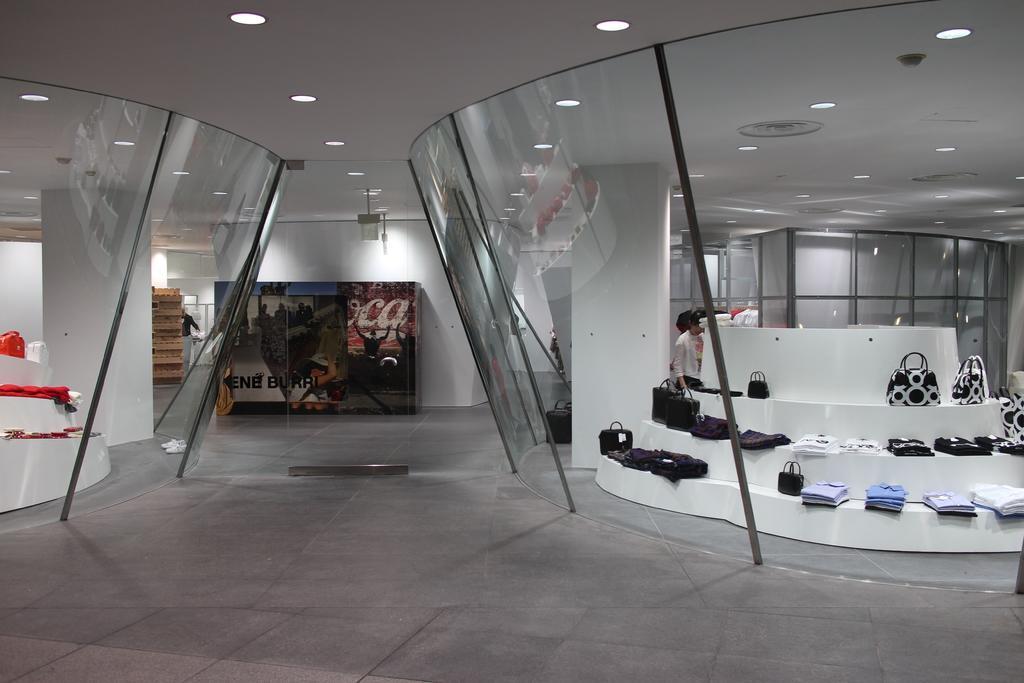How would you summarize this image in a sentence or two? On the right side, we see a stepped table on which the bags and the shirts are placed. Behind that, we see a pillar and a man is standing. Beside him, we see the poles, glass doors and a black bag. On the left side, we see the stepped table on which the clothes are placed. Behind that, we see a pillar, poles and the glass doors. In the middle, we see a board with some text written on it. Behind that, we see a wall. On the left side, we see the wooden blocks. In the background, we see a man is standing and we see the glass doors and the poles. At the top, we see the lights and the ceiling of the room. 